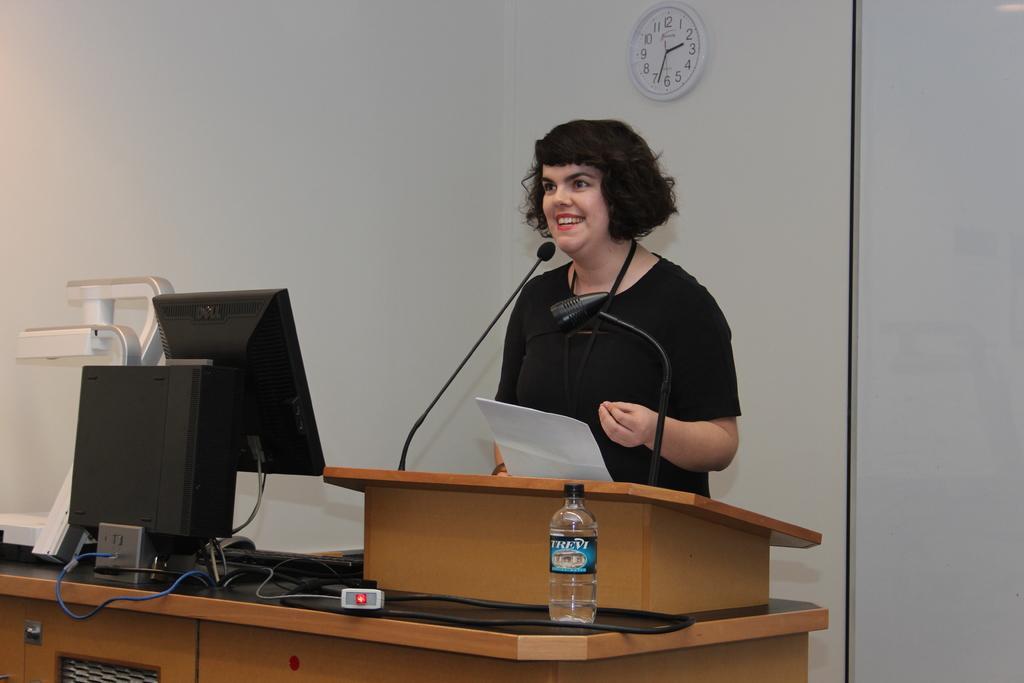Could you give a brief overview of what you see in this image? In this picture woman is standing and talking over microphone before table on which monitor , keyboard, mouse and bottle are there. Backside a clock is mounted on wall. 